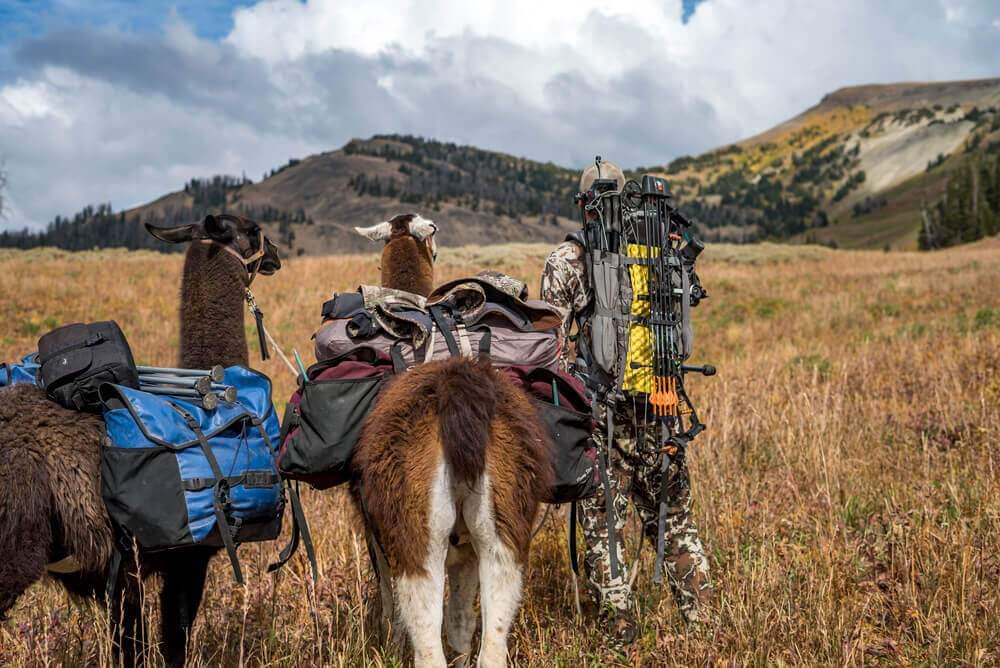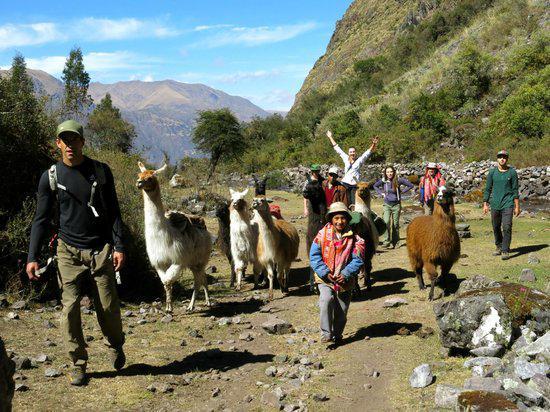The first image is the image on the left, the second image is the image on the right. For the images shown, is this caption "Some llamas are facing the other way." true? Answer yes or no. Yes. The first image is the image on the left, the second image is the image on the right. For the images shown, is this caption "The right image includes a person leading a llama toward the camera, and the left image includes multiple llamas wearing packs." true? Answer yes or no. Yes. 